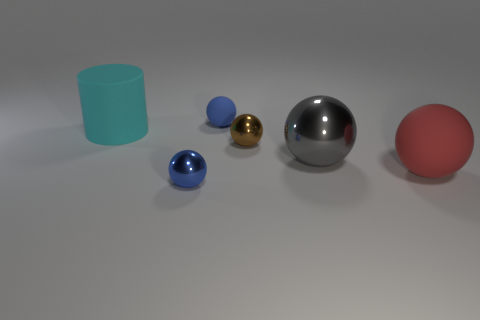There is a brown ball behind the blue sphere in front of the large rubber object behind the big red rubber thing; how big is it?
Provide a succinct answer. Small. The other object that is the same color as the small rubber thing is what size?
Give a very brief answer. Small. What number of things are either large blue rubber cylinders or red spheres?
Offer a very short reply. 1. The rubber thing that is in front of the small blue rubber sphere and on the left side of the gray sphere has what shape?
Your answer should be very brief. Cylinder. There is a brown shiny thing; is it the same shape as the big thing that is behind the gray ball?
Your answer should be very brief. No. Are there any gray objects on the left side of the small blue matte ball?
Your answer should be very brief. No. There is a ball that is the same color as the tiny matte object; what is its material?
Keep it short and to the point. Metal. What number of spheres are either large shiny things or green metallic things?
Your answer should be very brief. 1. Is the shape of the red object the same as the brown object?
Offer a very short reply. Yes. How big is the matte thing in front of the gray shiny sphere?
Keep it short and to the point. Large. 